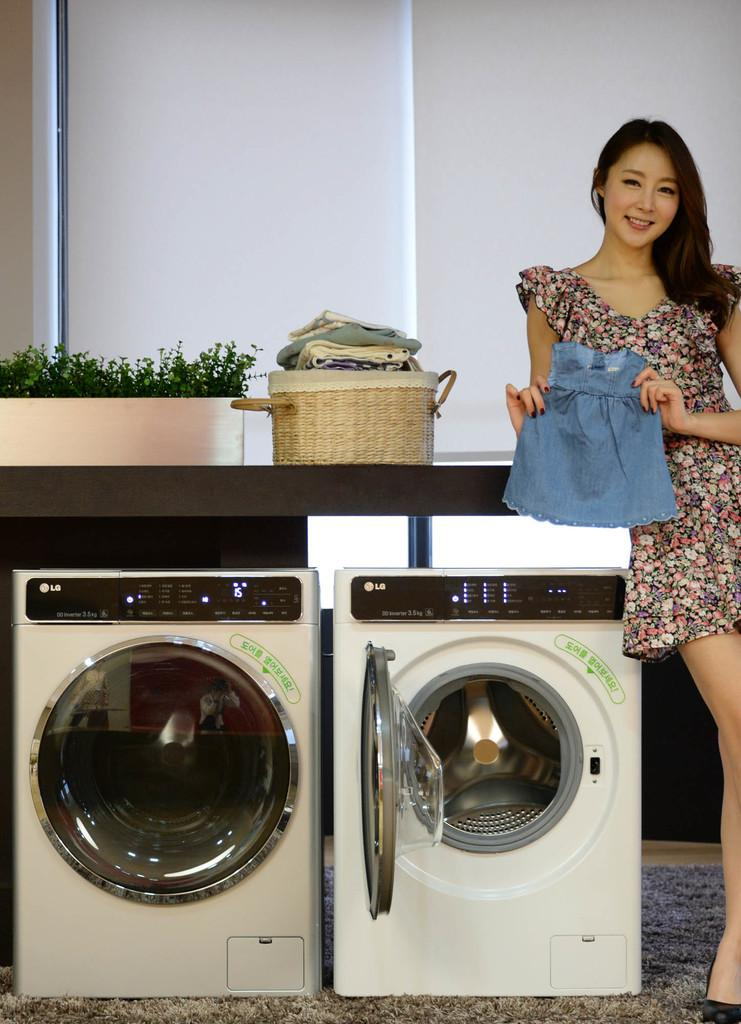Provide a one-sentence caption for the provided image. A girl holding up a child's outfit in front of LG laundry machines. 